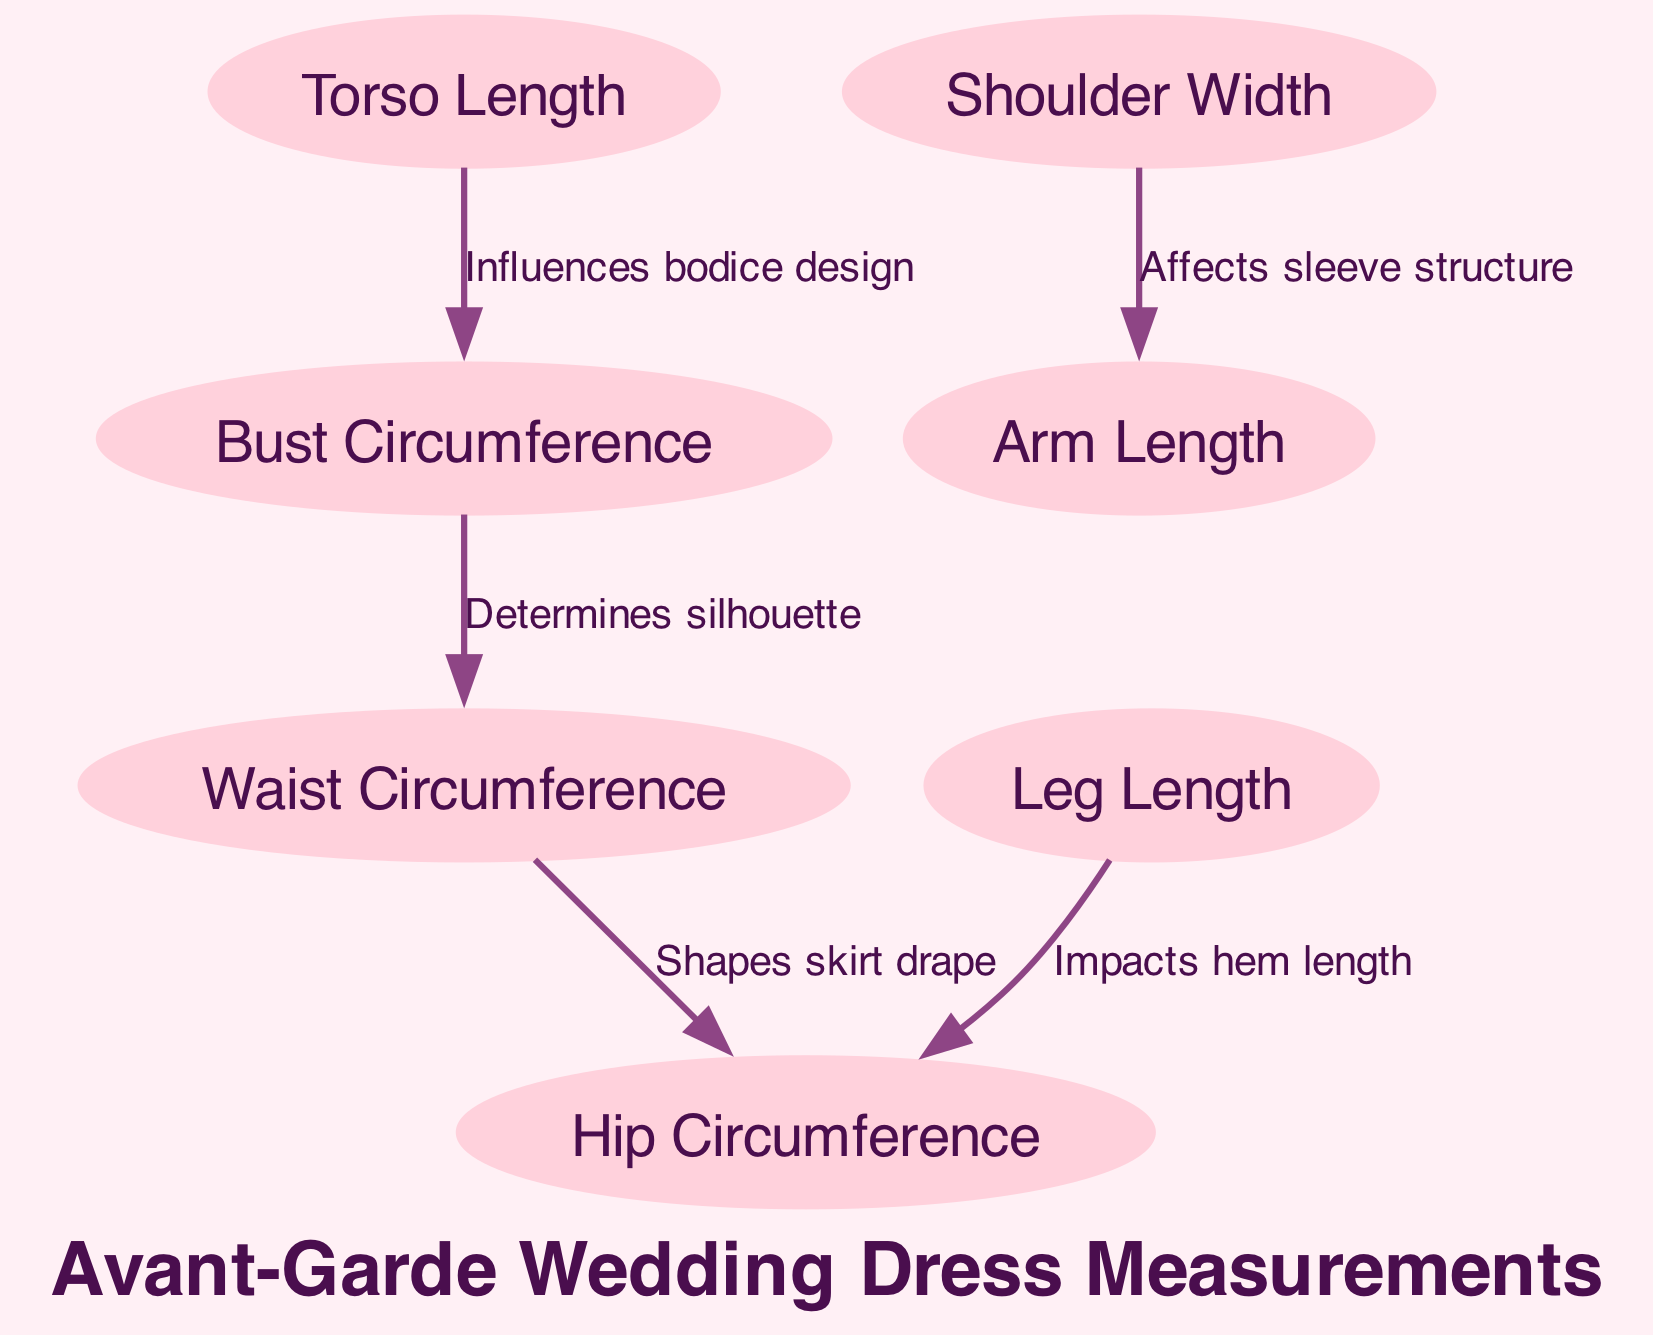What is the first measurement listed in the diagram? The diagram begins with the node "Torso Length," which is the first measurement mentioned in the list of nodes.
Answer: Torso Length How many nodes are present in the diagram? Counting the nodes labeled in the diagram, there are a total of 7 nodes corresponding to different body measurements.
Answer: 7 Which measurement influences the bodice design? The edge connecting "Torso Length" to "Bust Circumference" indicates that the torso length has a direct influence on the design of the bodice in dressmaking.
Answer: Torso Length What does "Waist Circumference" determine in the design? The connection from "Bust Circumference" to "Waist Circumference" denotes that the waist circumference plays a role in determining the overall silhouette of the dress, impacting its shape and style.
Answer: Silhouette How does "Leg Length" impact the overall design? The edge from "Leg Length" to "Hip Circumference" shows that the leg length affects the hem length of the dress, which is crucial for defining the dress's finishing touches at the bottom.
Answer: Hem length Which measurements are directly related by edges in the diagram? By examining the edges in the diagram, we can see that there are multiple direct relationships: Torso Length influences Bust Circumference, Bust Circumference determines Waist Circumference, Waist Circumference shapes Hip Circumference, and Leg Length impacts Hip Circumference.
Answer: Torso Length, Bust Circumference, Waist Circumference, Hip Circumference, Leg Length What effect does "Shoulder Width" have on the design? The connection between "Shoulder Width" and "Arm Length" signifies that shoulder width affects how the sleeve structure of the dress is created, impacting both comfort and style.
Answer: Sleeve structure 